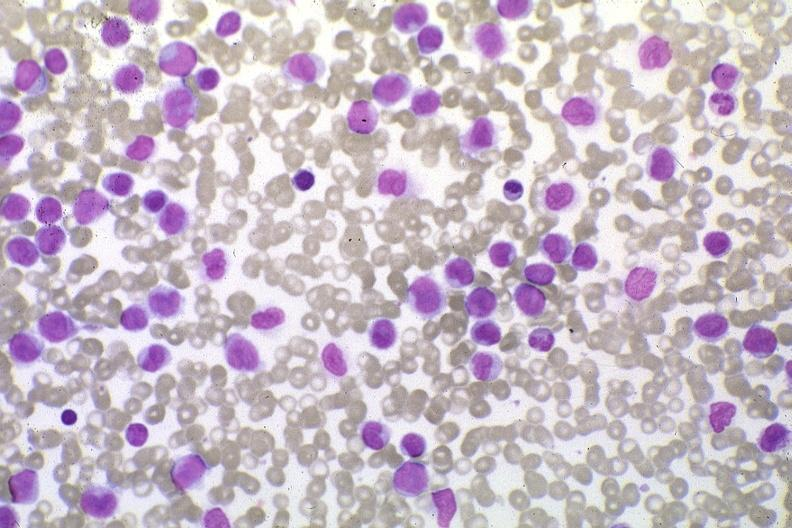what do wrights stain?
Answer the question using a single word or phrase. Pleomorphic leukemic cells in peripheral blood prior to therapy 